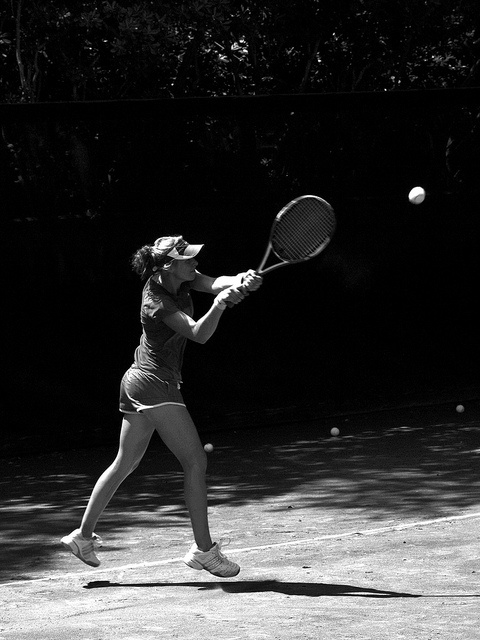Describe the objects in this image and their specific colors. I can see people in black, gray, lightgray, and darkgray tones, tennis racket in black, gray, darkgray, and lightgray tones, sports ball in black, whitesmoke, gray, and dimgray tones, sports ball in gray, black, and darkgray tones, and sports ball in gray and black tones in this image. 